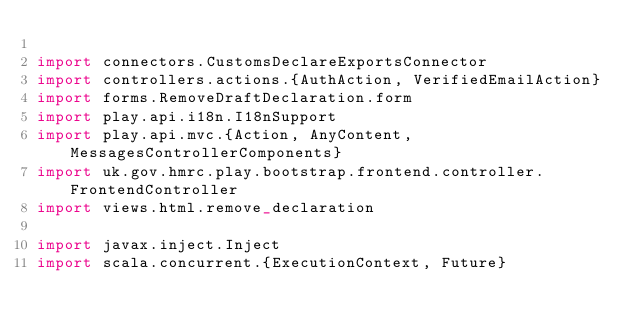Convert code to text. <code><loc_0><loc_0><loc_500><loc_500><_Scala_>
import connectors.CustomsDeclareExportsConnector
import controllers.actions.{AuthAction, VerifiedEmailAction}
import forms.RemoveDraftDeclaration.form
import play.api.i18n.I18nSupport
import play.api.mvc.{Action, AnyContent, MessagesControllerComponents}
import uk.gov.hmrc.play.bootstrap.frontend.controller.FrontendController
import views.html.remove_declaration

import javax.inject.Inject
import scala.concurrent.{ExecutionContext, Future}
</code> 